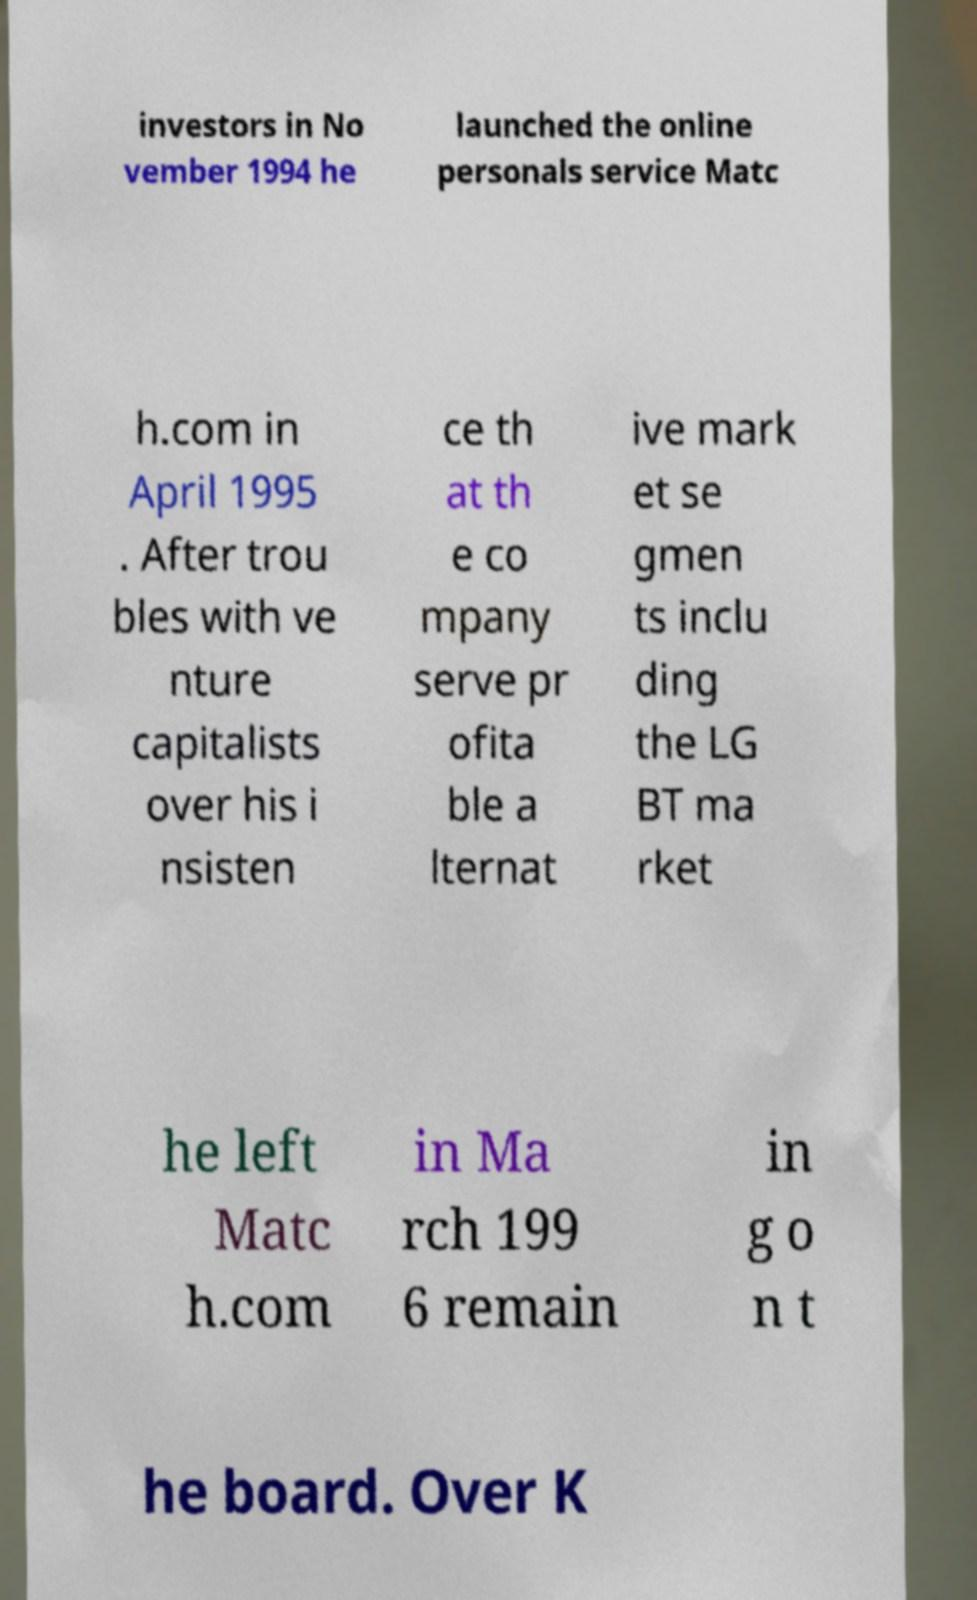What messages or text are displayed in this image? I need them in a readable, typed format. investors in No vember 1994 he launched the online personals service Matc h.com in April 1995 . After trou bles with ve nture capitalists over his i nsisten ce th at th e co mpany serve pr ofita ble a lternat ive mark et se gmen ts inclu ding the LG BT ma rket he left Matc h.com in Ma rch 199 6 remain in g o n t he board. Over K 